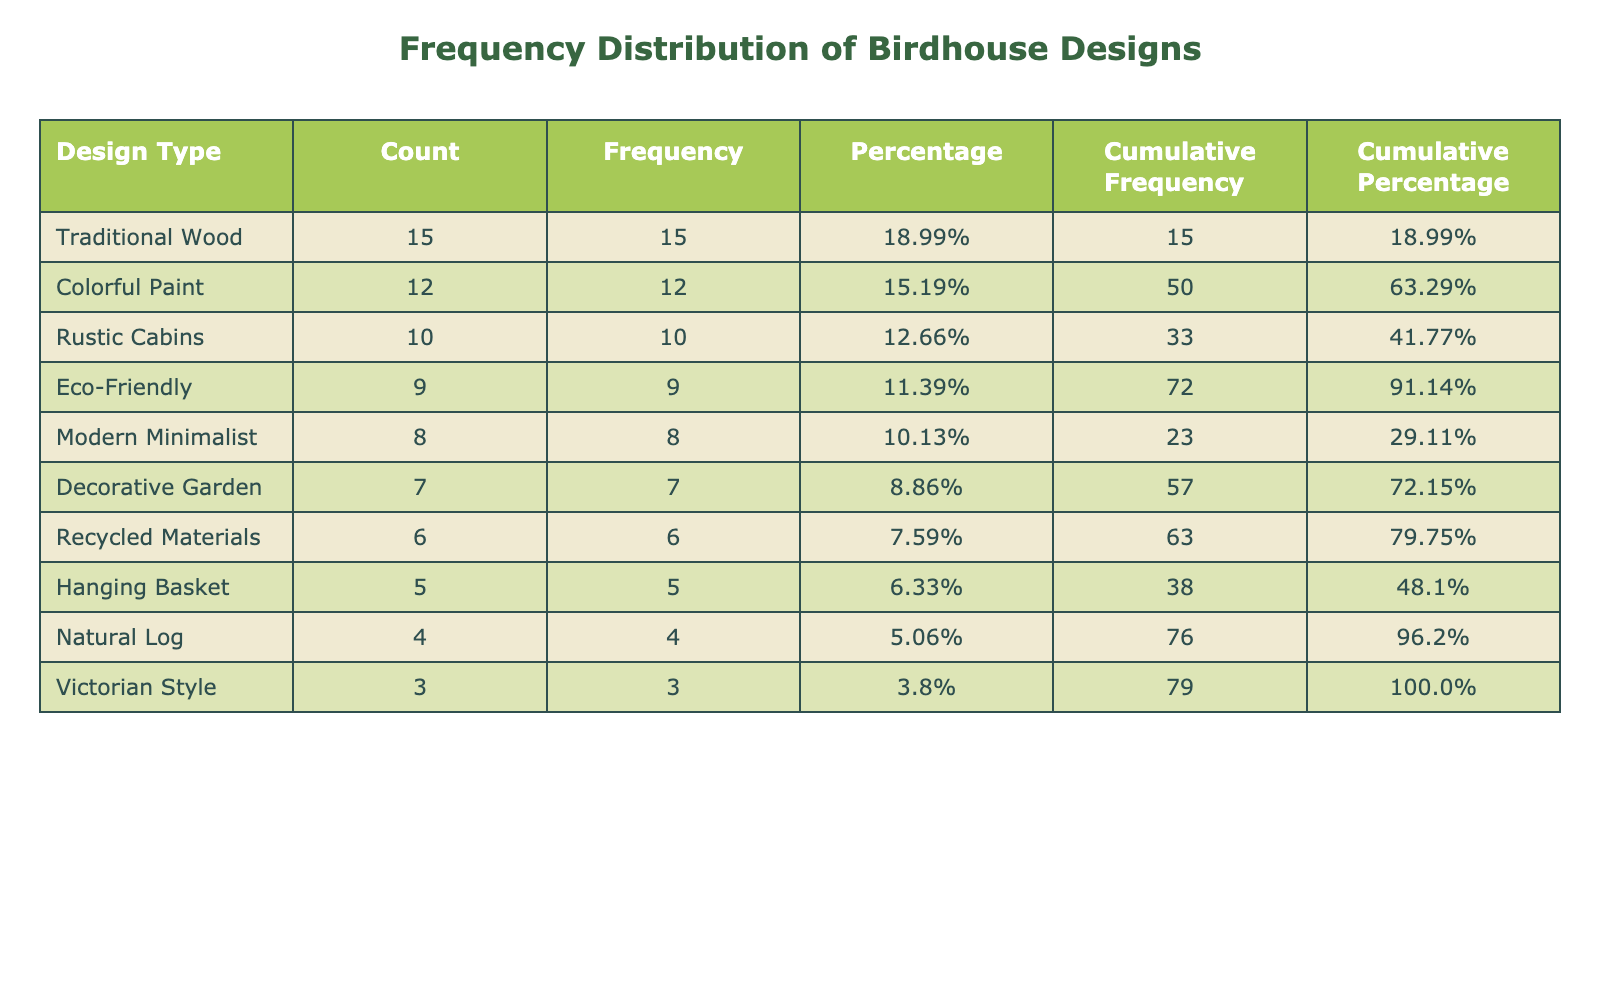What is the total count of birdhouses constructed? The total count is found by summing all the counts from the "Count" column: 15 + 8 + 10 + 5 + 12 + 7 + 6 + 9 + 4 + 3 = 79.
Answer: 79 Which design type has the highest count? The highest count can be identified by observing the "Count" column where "Traditional Wood" has the highest value of 15.
Answer: Traditional Wood What percentage of the birdhouses are made from "Colorful Paint"? To find the percentage, divide the count of "Colorful Paint" which is 12 by the total count of 79 and multiply by 100: (12/79) * 100 ≈ 15.19%.
Answer: Approximately 15.19% Is the count of "Hanging Basket" greater than the count of "Victorian Style"? By comparing the counts, "Hanging Basket" has a count of 5 and "Victorian Style" has a count of 3; therefore, 5 is greater than 3, so the statement is true.
Answer: Yes What is the cumulative percentage for the second design type listed? The second design type is "Modern Minimalist," which has a count of 8. To find its cumulative percentage, we first determine the cumulative frequency: 15 (Traditional Wood) + 8 (Modern Minimalist) = 23. The total is 79, so (23/79) * 100 ≈ 29.11%.
Answer: Approximately 29.11% How many design types have a count greater than 7? We can see from the table that the design types with counts greater than 7 are: "Traditional Wood" (15), "Colorful Paint" (12), "Rustic Cabins" (10), and "Eco-Friendly" (9). There are a total of 4 design types that meet this criterion.
Answer: 4 What is the difference between the count of "Rustic Cabins" and "Decorative Garden"? The count for "Rustic Cabins" is 10 and for "Decorative Garden" it is 7. The difference is calculated as 10 - 7 = 3.
Answer: 3 What is the average count of all the design types? To find the average, sum all the counts (79) and divide by the number of design types (10): 79 / 10 = 7.9.
Answer: 7.9 Are there more design types with an even count than with an odd count? The design types with even counts are: Rustic Cabins (10), Colorful Paint (12), Decorative Garden (7), and Victorian Style (3), totaling to 4 design types. The odd counts are 15 (Traditional Wood), 5 (Hanging Basket), 6 (Recycled Materials), and 9 (Eco-Friendly), totaling to 6 design types. Therefore, there are more odd counts.
Answer: No 